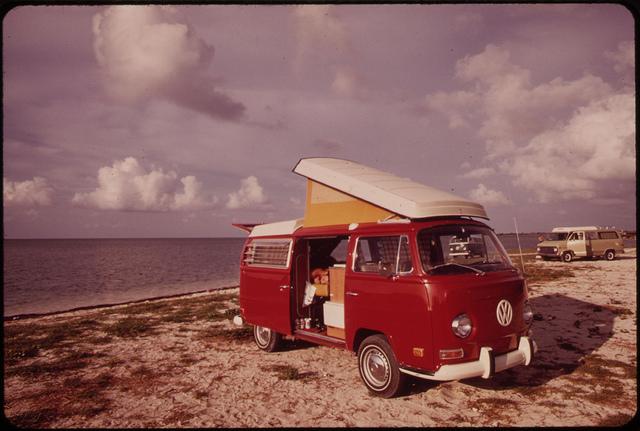Is this a beach scene?
Write a very short answer. Yes. Is this a camper?
Short answer required. Yes. Is that water in the background?
Quick response, please. Yes. What National Park is this?
Concise answer only. Yellowstone. Why is the roof of the van lifted?
Short answer required. Vent. What is the make of this vehicle?
Short answer required. Volkswagen. Are these objects life sized?
Give a very brief answer. Yes. 